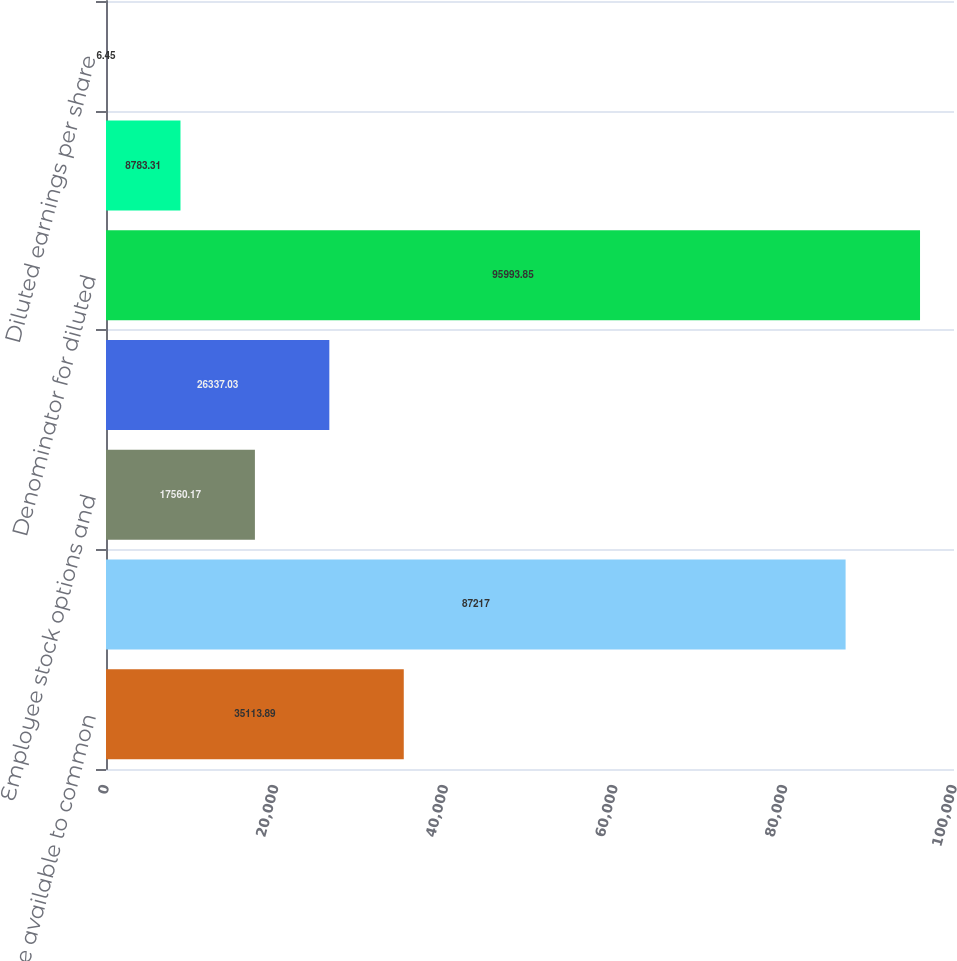<chart> <loc_0><loc_0><loc_500><loc_500><bar_chart><fcel>Net income available to common<fcel>Denominator for basic earnings<fcel>Employee stock options and<fcel>Restricted stock units<fcel>Denominator for diluted<fcel>Basic earnings per share<fcel>Diluted earnings per share<nl><fcel>35113.9<fcel>87217<fcel>17560.2<fcel>26337<fcel>95993.9<fcel>8783.31<fcel>6.45<nl></chart> 